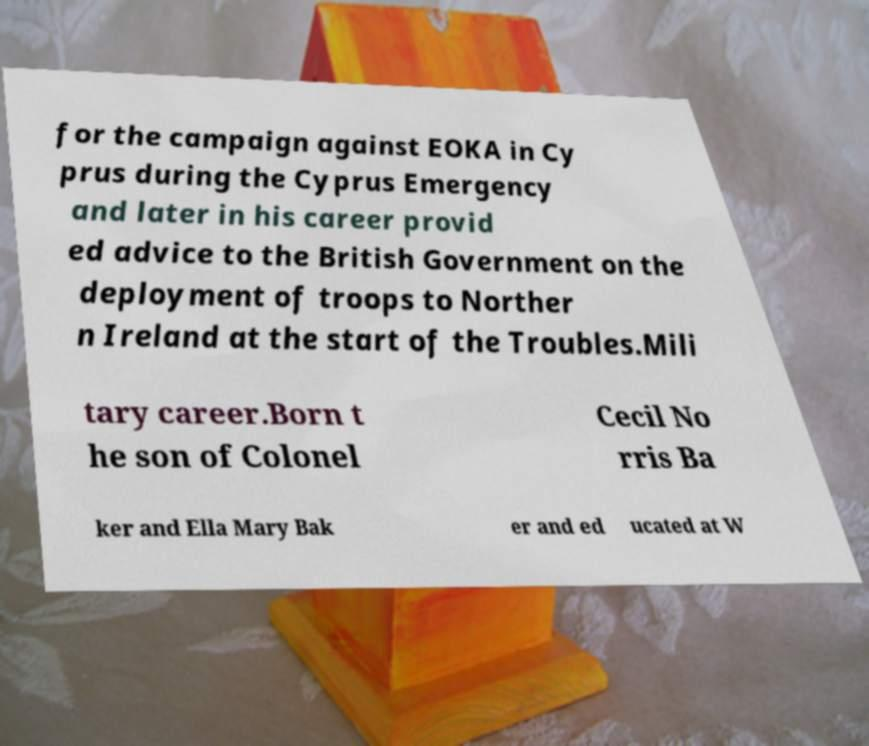Please read and relay the text visible in this image. What does it say? for the campaign against EOKA in Cy prus during the Cyprus Emergency and later in his career provid ed advice to the British Government on the deployment of troops to Norther n Ireland at the start of the Troubles.Mili tary career.Born t he son of Colonel Cecil No rris Ba ker and Ella Mary Bak er and ed ucated at W 